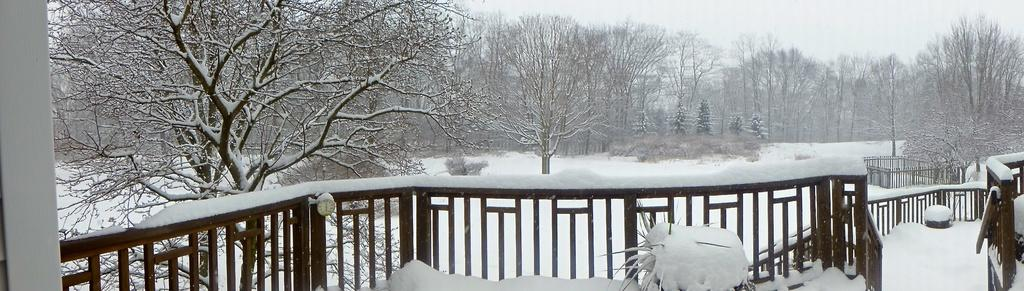What type of barrier can be seen in the image? There is a fence in the image. What is the ground covered with in the image? There is snow in the image. What type of vegetation is present in the image? There are plants and trees in the image. What is visible in the background of the image? The sky is visible in the image. What type of straw is being used by the committee in the image? There is no committee or straw present in the image. What color is the button on the tree in the image? There is no button on the tree in the image. 